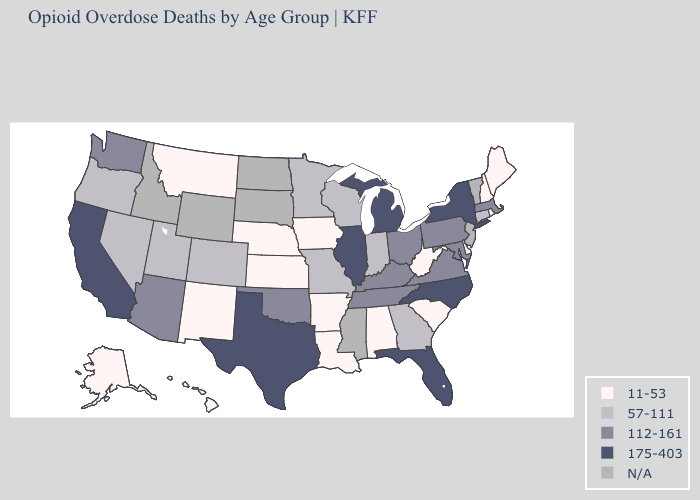What is the highest value in the USA?
Answer briefly. 175-403. What is the highest value in the MidWest ?
Give a very brief answer. 175-403. What is the highest value in the USA?
Short answer required. 175-403. Name the states that have a value in the range 112-161?
Answer briefly. Arizona, Kentucky, Maryland, Massachusetts, Ohio, Oklahoma, Pennsylvania, Tennessee, Virginia, Washington. Name the states that have a value in the range 175-403?
Concise answer only. California, Florida, Illinois, Michigan, New York, North Carolina, Texas. Among the states that border Texas , which have the lowest value?
Short answer required. Arkansas, Louisiana, New Mexico. What is the value of Kansas?
Keep it brief. 11-53. What is the value of Oregon?
Short answer required. 57-111. What is the highest value in the USA?
Quick response, please. 175-403. What is the highest value in states that border Oregon?
Concise answer only. 175-403. Which states have the highest value in the USA?
Concise answer only. California, Florida, Illinois, Michigan, New York, North Carolina, Texas. Name the states that have a value in the range 175-403?
Write a very short answer. California, Florida, Illinois, Michigan, New York, North Carolina, Texas. What is the value of Maine?
Concise answer only. 11-53. 